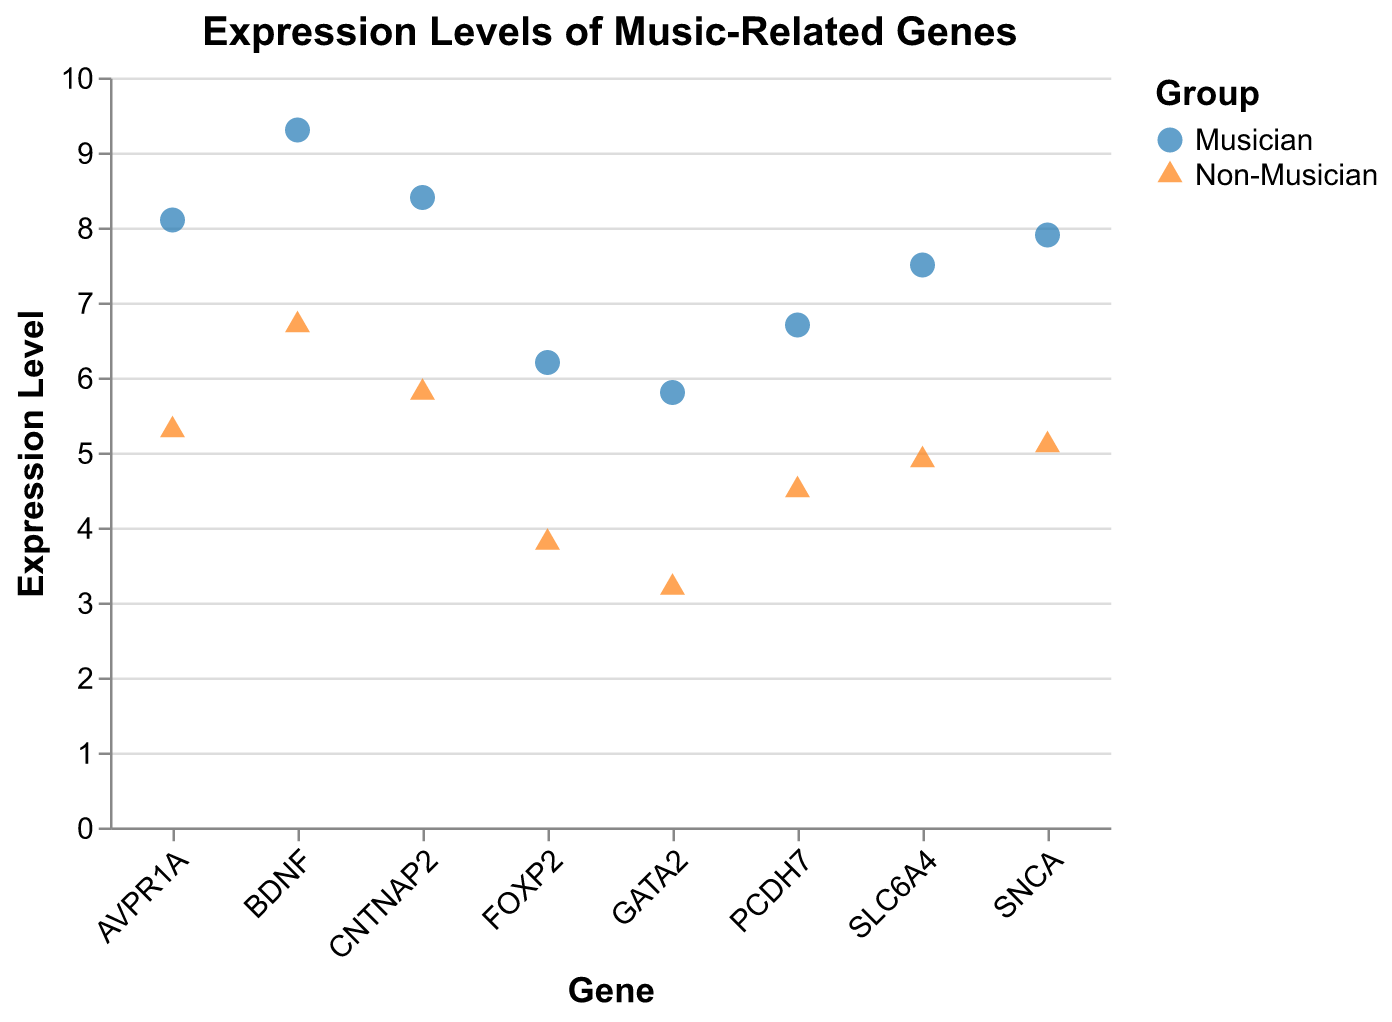What is the title of the figure? The title is written above the plot. It reads "Expression Levels of Music-Related Genes".
Answer: Expression Levels of Music-Related Genes Which group has higher expression levels across the genes? By visually comparing the data points for musicians and non-musicians across all genes, musicians consistently show higher expression levels.
Answer: Musicians What is the expression level of the FOXP2 gene in non-musicians? The figure shows a point at the intersection of the FOXP2 gene and non-musicians, which is located at the value of 3.8.
Answer: 3.8 By how much is the expression level of the AVPR1A gene higher in musicians compared to non-musicians? The expression levels for AVPR1A are 8.1 for musicians and 5.3 for non-musicians. Subtracting these gives 8.1 - 5.3 = 2.8.
Answer: 2.8 Which gene has the highest expression level for musicians? By checking the y-values of the points associated with musicians, the highest value is 9.3 for the BDNF gene.
Answer: BDNF What is the average expression level of the SLC6A4 gene across both groups? The SLC6A4 expression levels are 7.5 (musicians) and 4.9 (non-musicians). The average is (7.5 + 4.9) / 2 = 6.2.
Answer: 6.2 What shape represents the data points for non-musicians? The legend shows that non-musicians are represented by triangles. This is confirmed by triangular points on the plot.
Answer: Triangle What is the difference in expression levels of the GATA2 gene between musicians and non-musicians? The expression levels are 5.8 for musicians and 3.2 for non-musicians. The difference is 5.8 - 3.2 = 2.6.
Answer: 2.6 Which group has a wider range of expression levels for the CNTNAP2 gene? Checking the values, musicians have 8.4 and non-musicians have 5.8 for CNTNAP2. The range is higher for musicians as 8.4 - 5.8 = 2.6, while it's a single level for non-musicians.
Answer: Musicians 